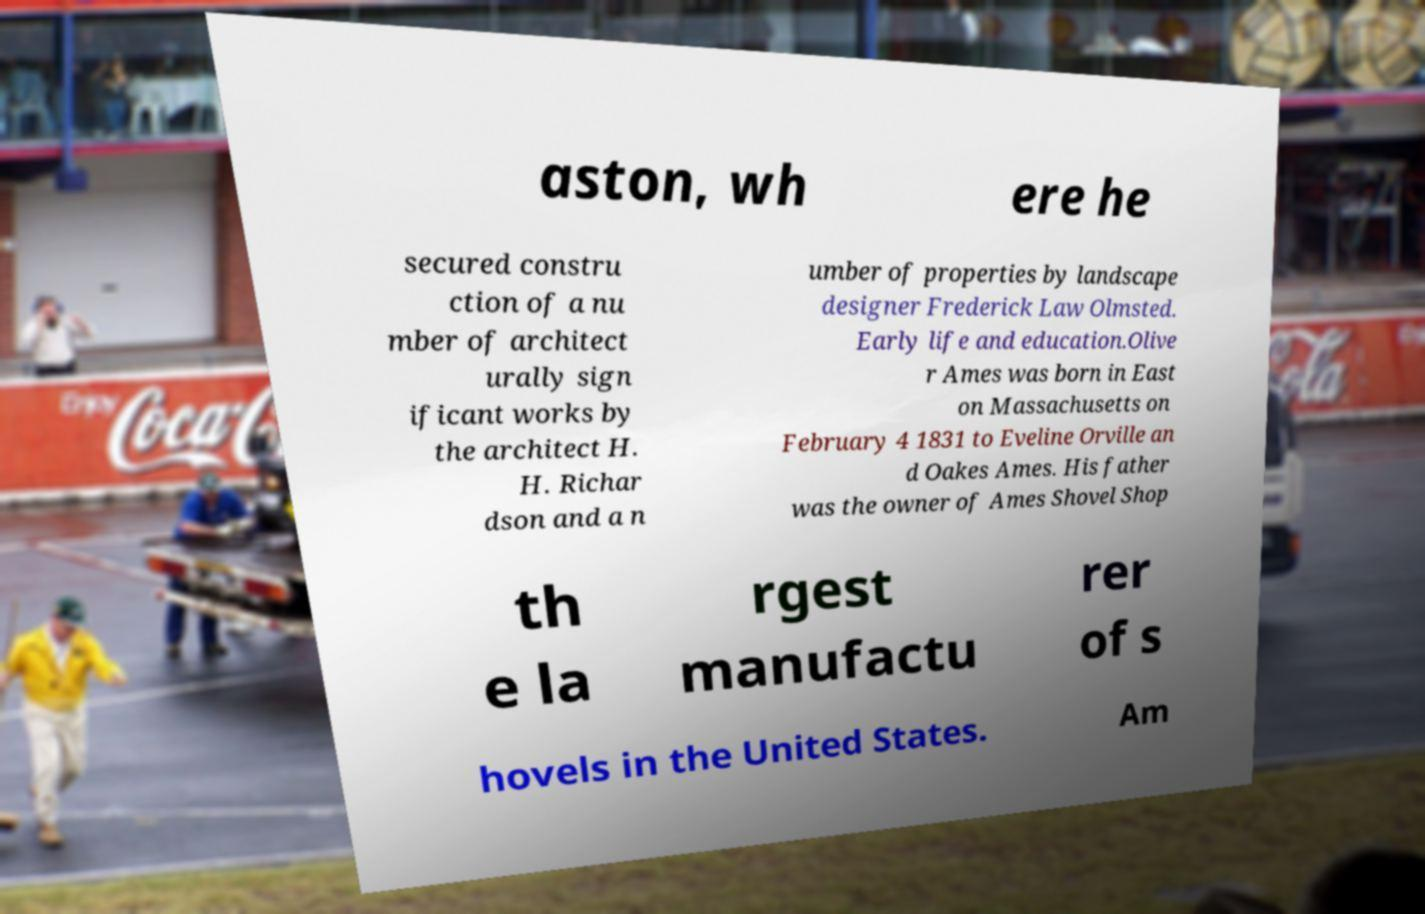For documentation purposes, I need the text within this image transcribed. Could you provide that? aston, wh ere he secured constru ction of a nu mber of architect urally sign ificant works by the architect H. H. Richar dson and a n umber of properties by landscape designer Frederick Law Olmsted. Early life and education.Olive r Ames was born in East on Massachusetts on February 4 1831 to Eveline Orville an d Oakes Ames. His father was the owner of Ames Shovel Shop th e la rgest manufactu rer of s hovels in the United States. Am 